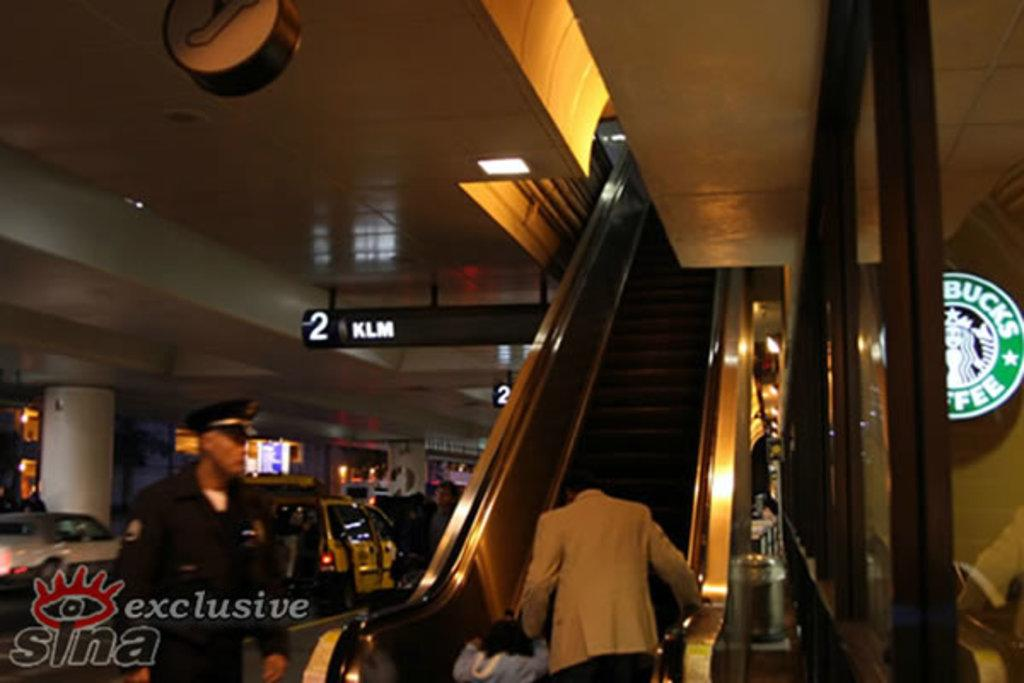What are the people in the image doing? There are persons on the escalator in the image. What can be used for finding directions or information in the image? There are information boards in the image. What type of transportation can be seen in the image? Motor vehicles are visible in the image. What can be used for identifying specific locations or areas in the image? Name boards are present in the image. Can you see any bombs in the image? There are no bombs present in the image. What type of quilt is being used to cover the motor vehicles in the image? There is no quilt present in the image, and the motor vehicles are not covered. 